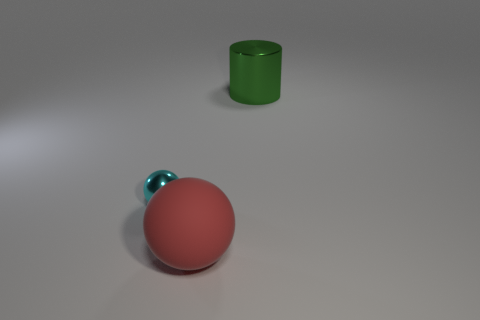Is there a green shiny object of the same size as the metal sphere?
Your answer should be very brief. No. Do the large red rubber object and the big green thing have the same shape?
Provide a succinct answer. No. Is there a big metallic thing that is to the right of the metal object that is on the left side of the metallic object that is to the right of the tiny cyan sphere?
Your answer should be compact. Yes. What number of other things are there of the same color as the tiny metallic ball?
Offer a terse response. 0. There is a object to the left of the rubber thing; is its size the same as the metallic object that is to the right of the big rubber object?
Provide a short and direct response. No. Is the number of small metallic spheres that are in front of the red ball the same as the number of cyan metal balls in front of the tiny shiny thing?
Offer a very short reply. Yes. Are there any other things that are the same material as the cyan sphere?
Make the answer very short. Yes. Is the size of the green object the same as the object that is on the left side of the large red sphere?
Provide a short and direct response. No. What material is the thing that is behind the shiny object in front of the green cylinder?
Provide a succinct answer. Metal. Are there an equal number of cylinders that are left of the cyan shiny ball and tiny objects?
Offer a terse response. No. 